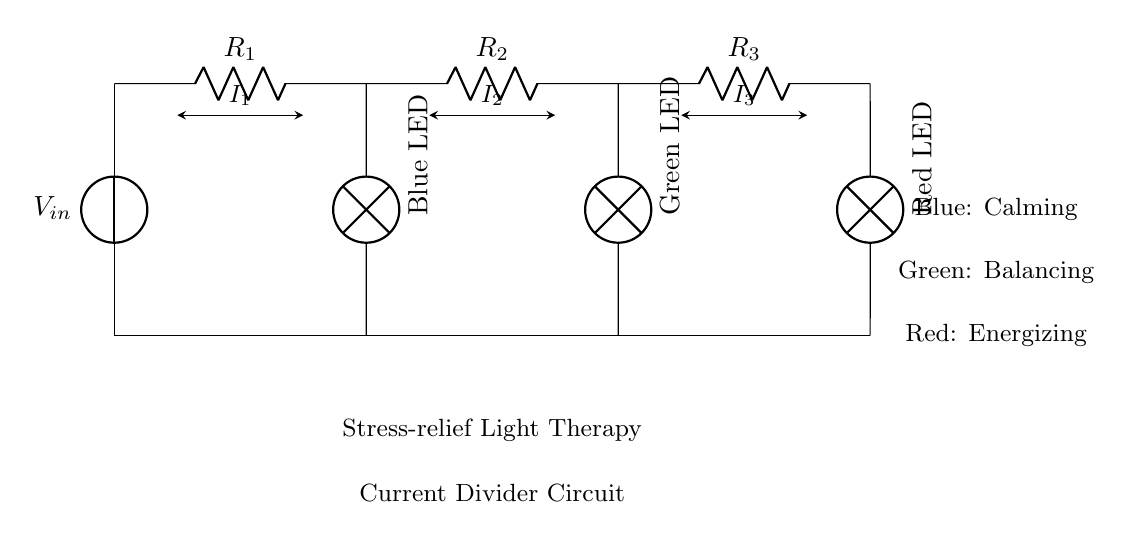What is the input voltage of the circuit? The input voltage is represented by \(V_{in}\), which indicates the potential difference provided to the circuit.
Answer: \(V_{in}\) How many resistors are in this circuit? There are three resistors in the circuit denoted as \(R_1\), \(R_2\), and \(R_3\).
Answer: 3 What colors of LEDs are used in this light therapy device? The circuit shows three LEDs, colored blue, green, and red, each serving different therapeutic purposes.
Answer: Blue, Green, Red Which LED is associated with calming effects? The blue LED is indicated in the diagram as providing calming effects.
Answer: Blue What is the purpose of using a current divider in this therapy circuit? The current divider allows different portions of the input current to flow through each LED, enabling tailored light therapy by adjusting the brightness or therapeutic effects.
Answer: Tailored light therapy What is the total current in the circuit? The total current can be considered as the sum of individual currents through each branch. A noteworthy characteristic of current dividers is that the total current splits across the resistors, but the specific total value isn't given in the diagram.
Answer: Not provided Which LED is meant to energize? The red LED is marked in the circuit as serving the energizing purpose.
Answer: Red 